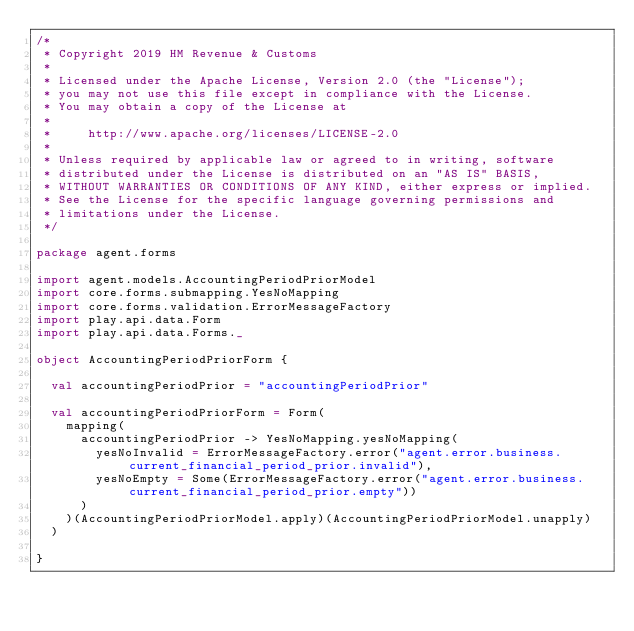<code> <loc_0><loc_0><loc_500><loc_500><_Scala_>/*
 * Copyright 2019 HM Revenue & Customs
 *
 * Licensed under the Apache License, Version 2.0 (the "License");
 * you may not use this file except in compliance with the License.
 * You may obtain a copy of the License at
 *
 *     http://www.apache.org/licenses/LICENSE-2.0
 *
 * Unless required by applicable law or agreed to in writing, software
 * distributed under the License is distributed on an "AS IS" BASIS,
 * WITHOUT WARRANTIES OR CONDITIONS OF ANY KIND, either express or implied.
 * See the License for the specific language governing permissions and
 * limitations under the License.
 */

package agent.forms

import agent.models.AccountingPeriodPriorModel
import core.forms.submapping.YesNoMapping
import core.forms.validation.ErrorMessageFactory
import play.api.data.Form
import play.api.data.Forms._

object AccountingPeriodPriorForm {

  val accountingPeriodPrior = "accountingPeriodPrior"

  val accountingPeriodPriorForm = Form(
    mapping(
      accountingPeriodPrior -> YesNoMapping.yesNoMapping(
        yesNoInvalid = ErrorMessageFactory.error("agent.error.business.current_financial_period_prior.invalid"),
        yesNoEmpty = Some(ErrorMessageFactory.error("agent.error.business.current_financial_period_prior.empty"))
      )
    )(AccountingPeriodPriorModel.apply)(AccountingPeriodPriorModel.unapply)
  )

}
</code> 